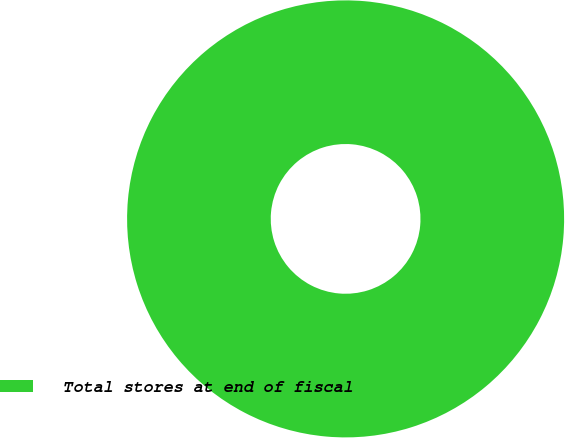<chart> <loc_0><loc_0><loc_500><loc_500><pie_chart><fcel>Total stores at end of fiscal<nl><fcel>100.0%<nl></chart> 